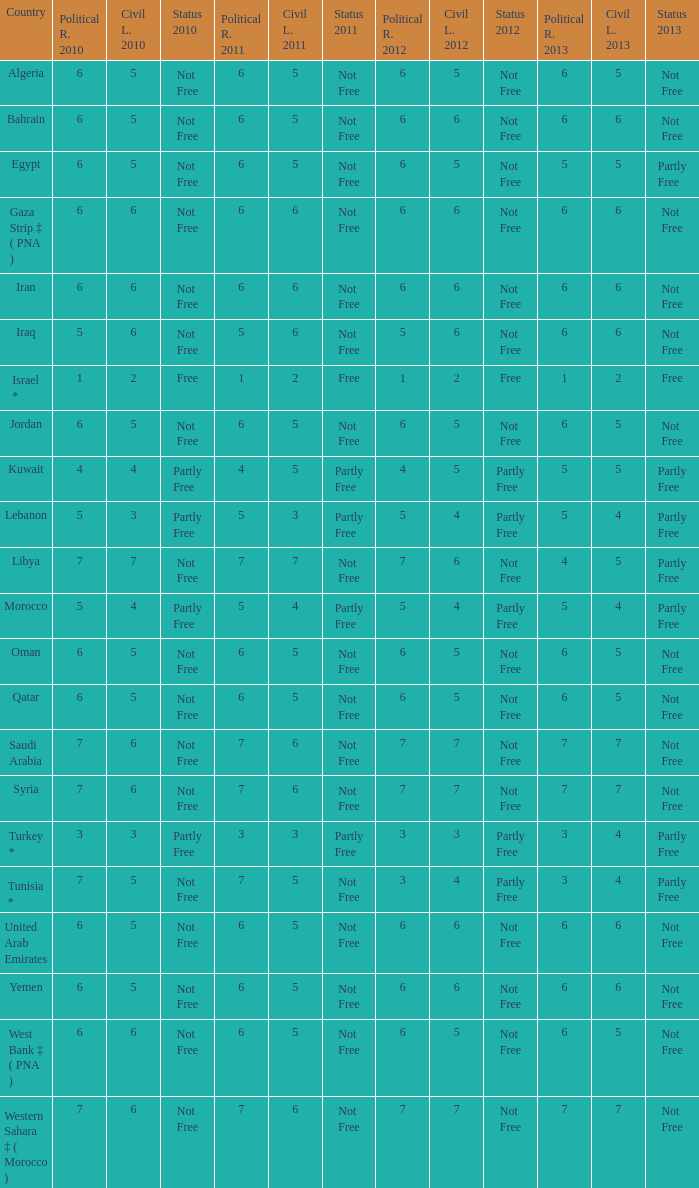How many civil liberties 2013 values are associated with a 2010 political rights value of 6, civil liberties 2012 values over 5, and political rights 2011 under 6? 0.0. 